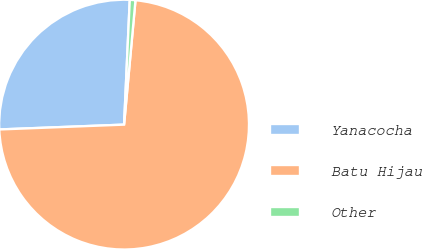Convert chart to OTSL. <chart><loc_0><loc_0><loc_500><loc_500><pie_chart><fcel>Yanacocha<fcel>Batu Hijau<fcel>Other<nl><fcel>26.34%<fcel>72.93%<fcel>0.73%<nl></chart> 